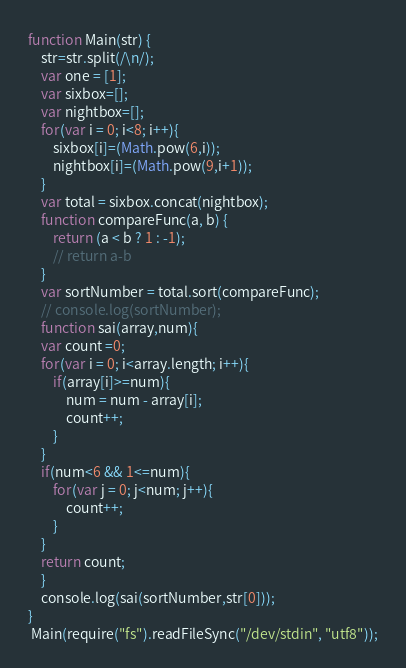Convert code to text. <code><loc_0><loc_0><loc_500><loc_500><_JavaScript_>function Main(str) {
    str=str.split(/\n/);
    var one = [1];
    var sixbox=[];
    var nightbox=[];
    for(var i = 0; i<8; i++){
        sixbox[i]=(Math.pow(6,i));
        nightbox[i]=(Math.pow(9,i+1));
    }
    var total = sixbox.concat(nightbox);
    function compareFunc(a, b) {
        return (a < b ? 1 : -1);
        // return a-b
    }
    var sortNumber = total.sort(compareFunc);
    // console.log(sortNumber);
    function sai(array,num){
    var count =0;
    for(var i = 0; i<array.length; i++){
        if(array[i]>=num){
            num = num - array[i];
            count++;
        }
    }
    if(num<6 && 1<=num){
        for(var j = 0; j<num; j++){
            count++;
        }
    }
    return count;
    }
    console.log(sai(sortNumber,str[0]));
}
 Main(require("fs").readFileSync("/dev/stdin", "utf8"));</code> 